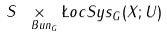<formula> <loc_0><loc_0><loc_500><loc_500>S \underset { \ B u n _ { G } } \times \L o c S y s _ { G } ( X ; U )</formula> 